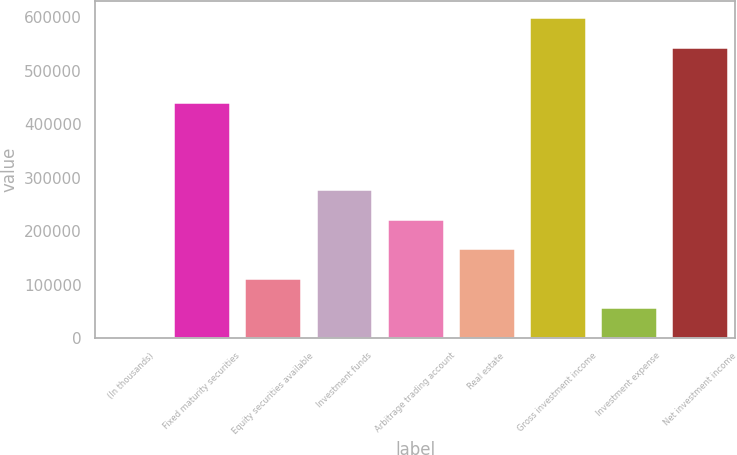Convert chart. <chart><loc_0><loc_0><loc_500><loc_500><bar_chart><fcel>(In thousands)<fcel>Fixed maturity securities<fcel>Equity securities available<fcel>Investment funds<fcel>Arbitrage trading account<fcel>Real estate<fcel>Gross investment income<fcel>Investment expense<fcel>Net investment income<nl><fcel>2013<fcel>442287<fcel>112472<fcel>278160<fcel>222931<fcel>167702<fcel>599520<fcel>57242.5<fcel>544291<nl></chart> 